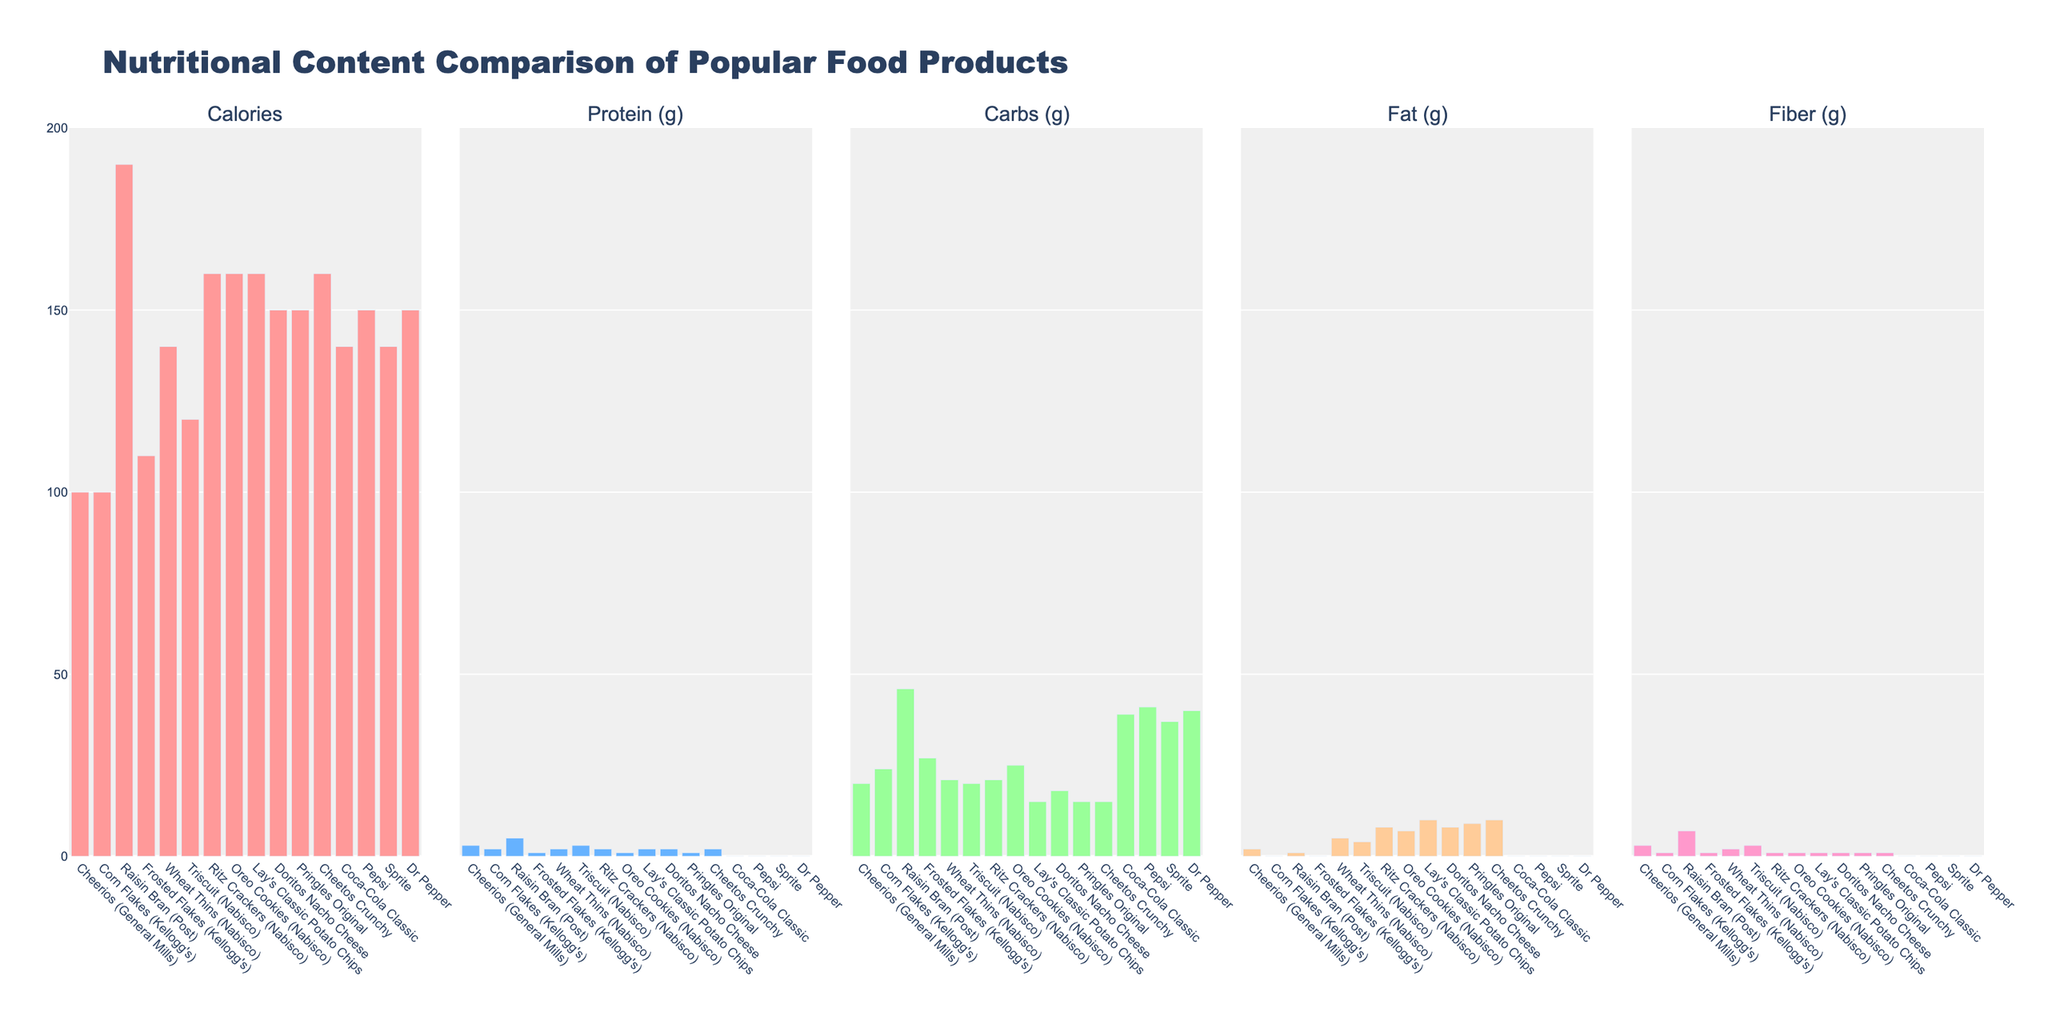Which product has the highest carbohydrate content? By looking at the bar height for carbohydrates, Raisin Bran (Post) has the tallest bar, indicating it has the highest carbohydrate content.
Answer: Raisin Bran (Post) Which product contains the lowest amount of protein? Examining the protein content bars, Coca-Cola Classic, Pepsi, Sprite, and Dr Pepper all have no protein as their bars are flat at zero.
Answer: Coca-Cola Classic, Pepsi, Sprite, Dr Pepper What is the difference in fat content between Lay's Classic Potato Chips and Pringles Original? Lay's Classic Potato Chips have a bar showing 10g of fat, while Pringles Original has a bar showing 9g of fat. The difference is 10g - 9g = 1g.
Answer: 1g Which product has the highest fiber content and how much is it? The tallest bar in the fiber category belongs to Raisin Bran (Post) with a fiber content of 7g.
Answer: Raisin Bran (Post) with 7g Between Cheerios (General Mills) and Corn Flakes (Kellogg's), which one has higher calories? Comparing the bar heights in the calories category, both Cheerios (General Mills) and Corn Flakes (Kellogg's) have bars at the same height indicating 100 calories each.
Answer: Both are equal Are there any products with equal fat content? If so, which ones and what is the value? By comparing the bars in the fat category, Frosted Flakes (Kellogg's) and Coca-Cola Classic both have bars at 0g fat.
Answer: Frosted Flakes (Kellogg's), Coca-Cola Classic with 0g What is the average fiber content of Nabisco products listed? The Nabisco products listed are Wheat Thins (2g), Triscuit (3g), Ritz Crackers (1g), and Oreo Cookies (1g). Adding them together: 2 + 3 + 1 + 1 = 7g. Average: 7g / 4 = 1.75g.
Answer: 1.75g Which product has the highest calorie content between the listed soft drinks? By examining the calories bars for soft drinks (Coca-Cola Classic, Pepsi, Sprite, Dr Pepper), all bars rest at 140-150 calories with Pepsi and Dr Pepper being the highest at 150 calories.
Answer: Pepsi, Dr Pepper 